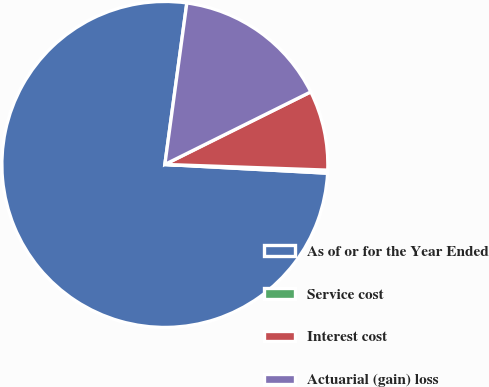Convert chart. <chart><loc_0><loc_0><loc_500><loc_500><pie_chart><fcel>As of or for the Year Ended<fcel>Service cost<fcel>Interest cost<fcel>Actuarial (gain) loss<nl><fcel>76.29%<fcel>0.3%<fcel>7.9%<fcel>15.5%<nl></chart> 